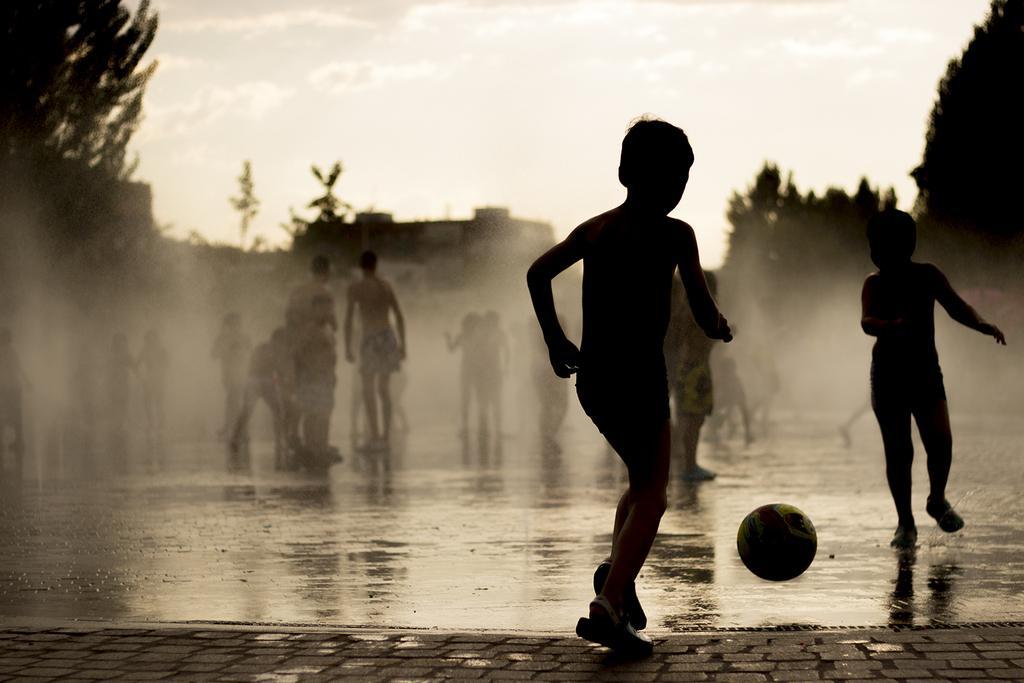In one or two sentences, can you explain what this image depicts? This is a black and white picture, in this image we can see a few people on the ground, among them some are playing with a ball, there are some buildings and trees. 